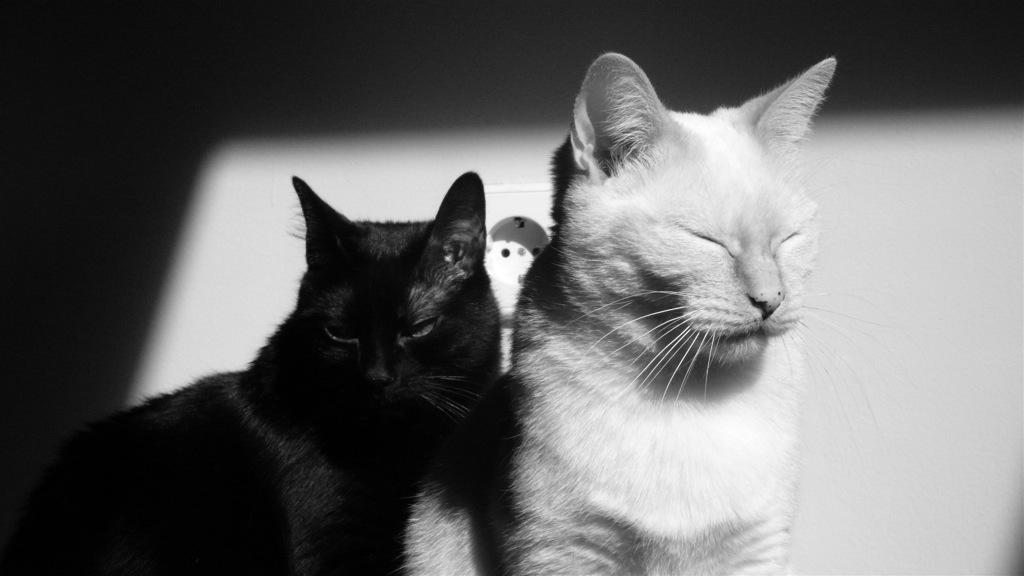Could you give a brief overview of what you see in this image? In this image in the foreground there are two cats, and in the background there is a wall. 